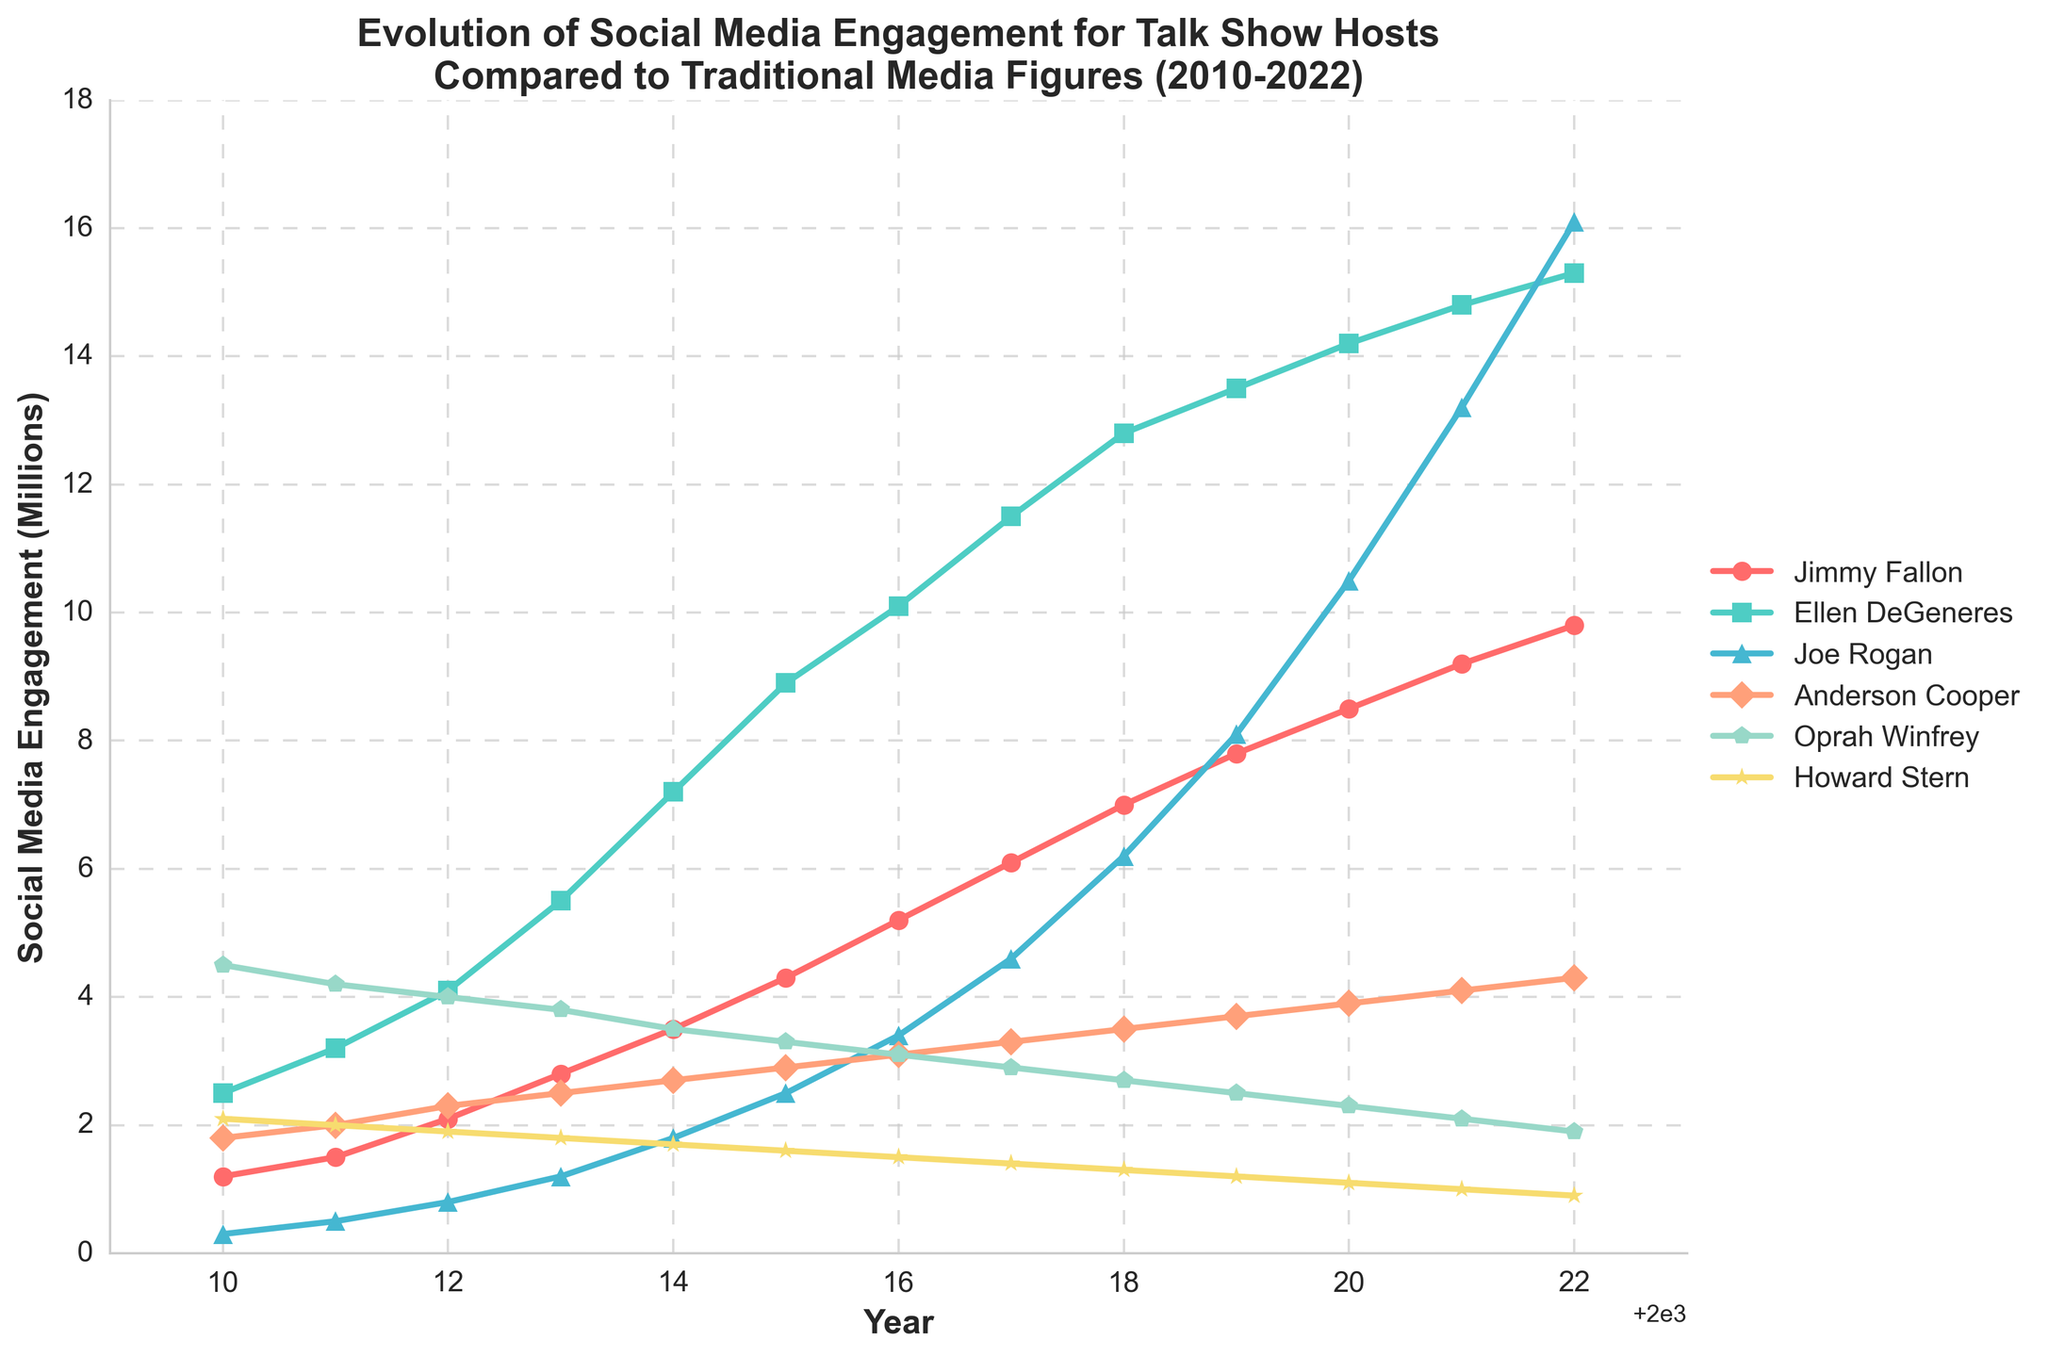What is the overall trend of social media engagement for Joe Rogan from 2010 to 2022? The social media engagement for Joe Rogan shows a steady increase from 0.3 million in 2010 to 16.1 million in 2022. This indicates a significant growth over the years.
Answer: Increasing Who had the highest social media engagement in 2010, and who had the highest in 2022? In 2010, Oprah Winfrey had the highest social media engagement at 4.5 million. In 2022, Ellen DeGeneres had the highest social media engagement at 15.3 million.
Answer: Oprah Winfrey (2010), Ellen DeGeneres (2022) Between 2015 and 2020, who experienced the largest increase in social media engagement? Joe Rogan experienced the largest increase in social media engagement, rising from 2.5 million in 2015 to 10.5 million in 2020, an increase of 8 million.
Answer: Joe Rogan By how much did Jimmy Fallon's social media engagement grow from 2014 to 2017? Jimmy Fallon's social media engagement grew from 3.5 million in 2014 to 6.1 million in 2017. The difference is 6.1 - 3.5 = 2.6 million.
Answer: 2.6 million Compare the social media engagement of Anderson Cooper and Howard Stern in 2022. Who has more, and by how much? In 2022, Anderson Cooper had 4.3 million, while Howard Stern had 0.9 million. Anderson Cooper had 4.3 - 0.9 = 3.4 million more social media engagement than Howard Stern.
Answer: Anderson Cooper, 3.4 million more What is the average social media engagement of Oprah Winfrey from 2010 to 2022? Sum the social media engagement values for Oprah Winfrey from 2010 to 2022: 4.5 + 4.2 + 4.0 + 3.8 + 3.5 + 3.3 + 3.1 + 2.9 + 2.7 + 2.5 + 2.3 + 2.1 + 1.9 = 40.8. There are 13 years in total, so the average is 40.8 / 13 ≈ 3.14 million.
Answer: ≈ 3.14 million During which year did Ellen DeGeneres surpass 10 million in social media engagement, and what was the exact value that year? Ellen DeGeneres surpassed 10 million in social media engagement in 2016, with an exact value of 10.1 million.
Answer: 2016, 10.1 million What is the difference in social media engagement between the highest and the lowest talk show host in 2022? In 2022, Ellen DeGeneres had the highest social media engagement at 15.3 million, and Howard Stern had the lowest at 0.9 million. The difference is 15.3 - 0.9 = 14.4 million.
Answer: 14.4 million Which host had a decreasing trend in social media engagement from 2010 to 2022? Howard Stern's social media engagement decreased from 2.1 million in 2010 to 0.9 million in 2022, indicating a decreasing trend.
Answer: Howard Stern 